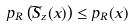Convert formula to latex. <formula><loc_0><loc_0><loc_500><loc_500>p _ { R } \left ( \widetilde { S } _ { z } ( x ) \right ) \leq p _ { R } ( x )</formula> 